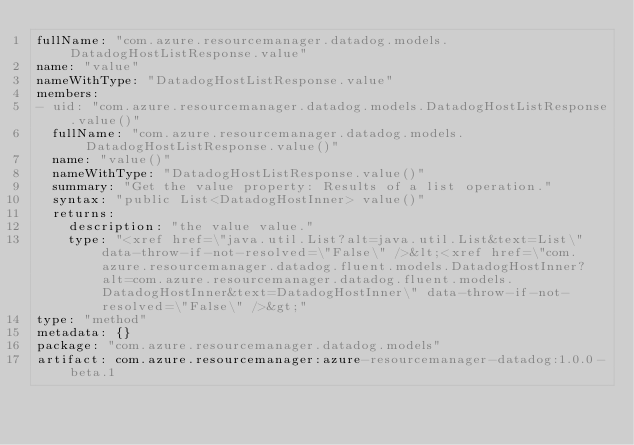Convert code to text. <code><loc_0><loc_0><loc_500><loc_500><_YAML_>fullName: "com.azure.resourcemanager.datadog.models.DatadogHostListResponse.value"
name: "value"
nameWithType: "DatadogHostListResponse.value"
members:
- uid: "com.azure.resourcemanager.datadog.models.DatadogHostListResponse.value()"
  fullName: "com.azure.resourcemanager.datadog.models.DatadogHostListResponse.value()"
  name: "value()"
  nameWithType: "DatadogHostListResponse.value()"
  summary: "Get the value property: Results of a list operation."
  syntax: "public List<DatadogHostInner> value()"
  returns:
    description: "the value value."
    type: "<xref href=\"java.util.List?alt=java.util.List&text=List\" data-throw-if-not-resolved=\"False\" />&lt;<xref href=\"com.azure.resourcemanager.datadog.fluent.models.DatadogHostInner?alt=com.azure.resourcemanager.datadog.fluent.models.DatadogHostInner&text=DatadogHostInner\" data-throw-if-not-resolved=\"False\" />&gt;"
type: "method"
metadata: {}
package: "com.azure.resourcemanager.datadog.models"
artifact: com.azure.resourcemanager:azure-resourcemanager-datadog:1.0.0-beta.1
</code> 